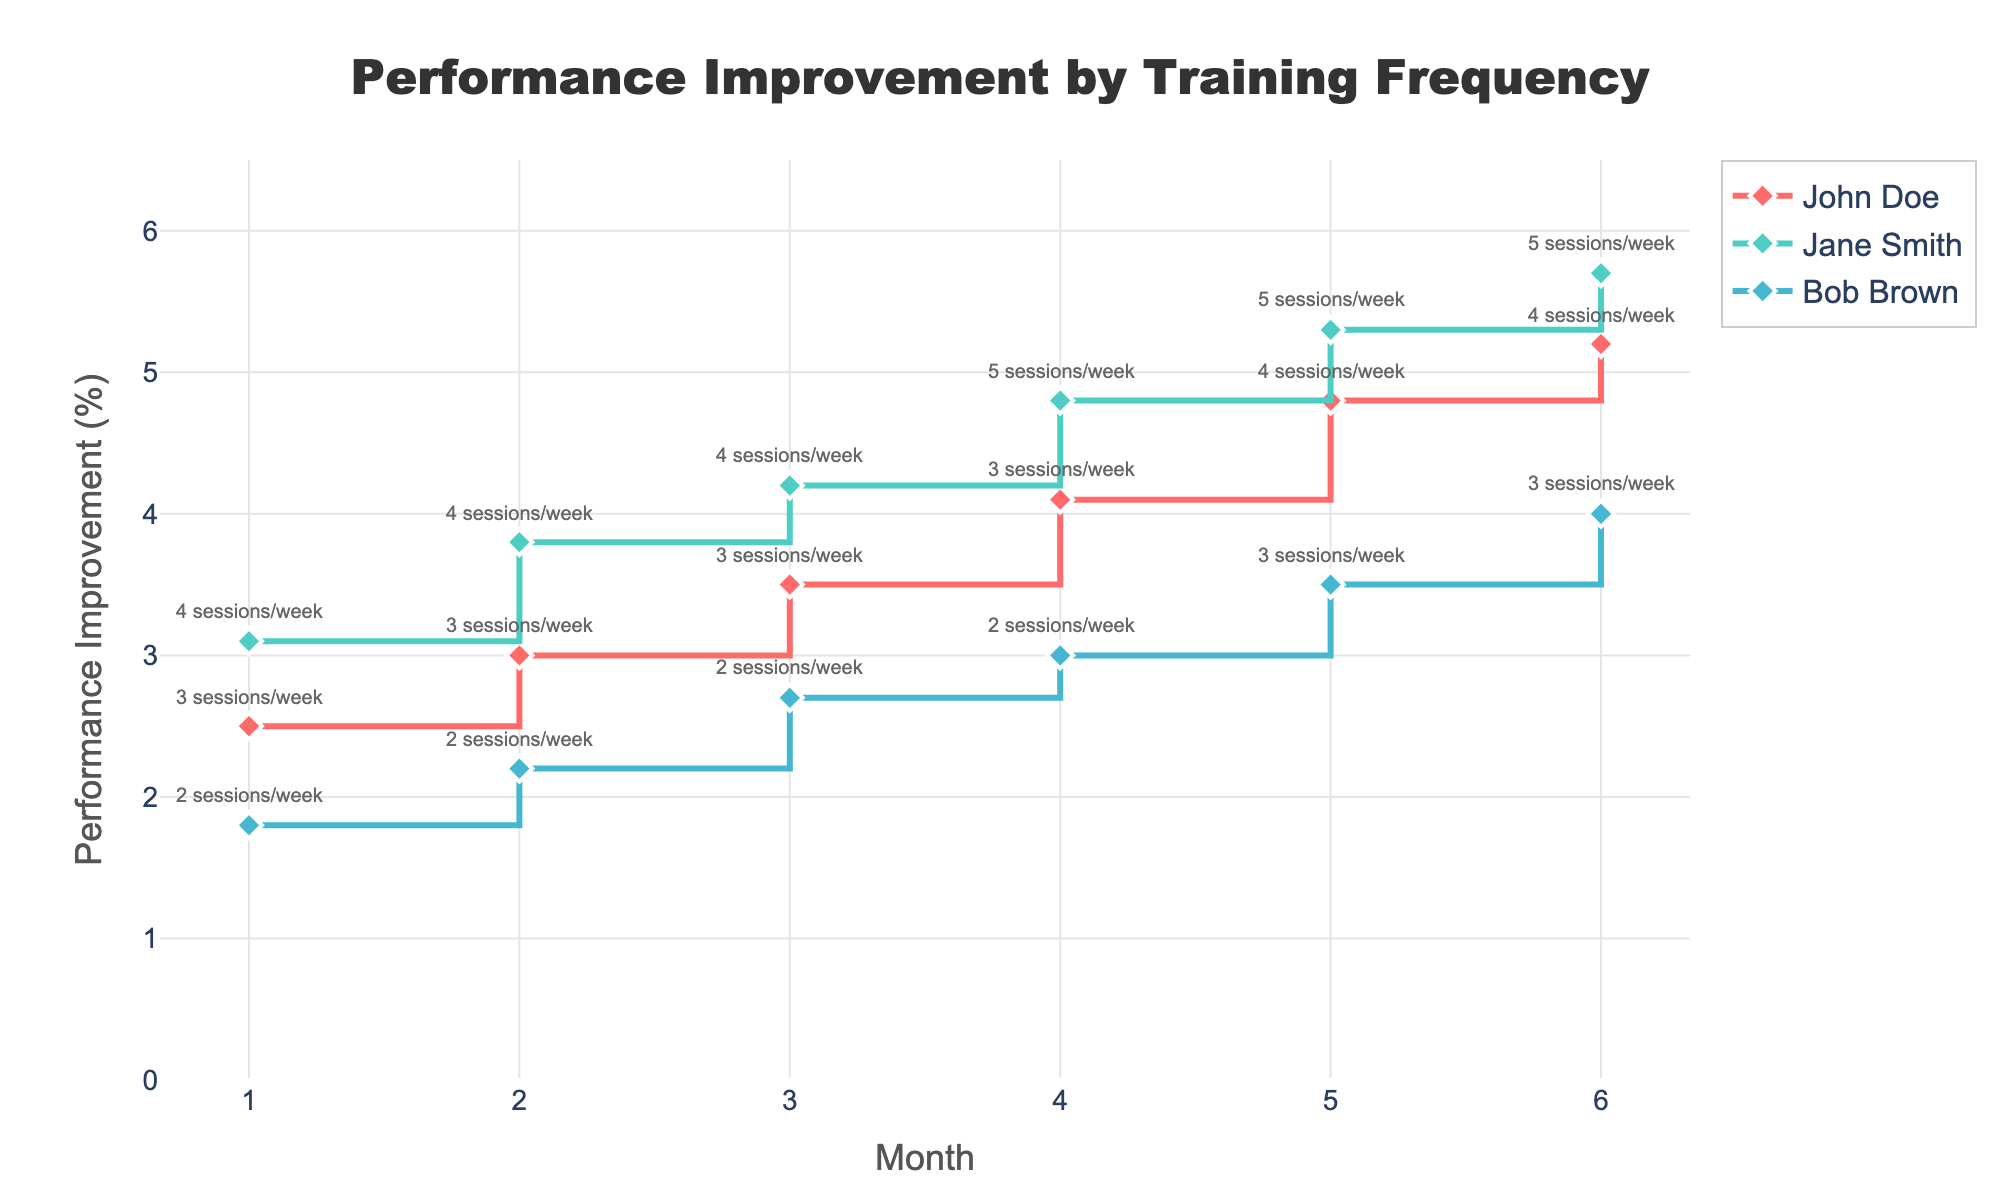What is the title of the plot? The title is displayed at the top of the plot and reads "Performance Improvement by Training Frequency".
Answer: Performance Improvement by Training Frequency How many athletes' performance improvements are tracked in the plot? The legend in the plot lists each athlete being tracked. There are three athletes shown: John Doe, Jane Smith, and Bob Brown.
Answer: 3 Which athlete has the highest performance improvement in Month 6? From the data points in Month 6, Jane Smith has the highest performance improvement at 5.7%.
Answer: Jane Smith What is the average performance improvement for Bob Brown over the 6 months? Calculate Bob Brown’s performance improvements for each month: 1.8, 2.2, 2.7, 3.0, 3.5, and 4.0. Sum these values and divide by the number of months (6). The sum is 17.2, so the average is 17.2/6.
Answer: 2.87% How did John Doe's training frequency change from Month 3 to Month 5? In Month 3, John Doe's training frequency was 3 sessions/week. By Month 5, it increased to 4 sessions/week.
Answer: Increased Who had the most consistent training frequency over the 6 months? By examining the annotations, we can see that Bob Brown maintained a consistent frequency of 2 sessions/week for the first 4 months before increasing to 3 sessions/week in the last 2 months. Therefore, Bob Brown had the most consistent training frequency.
Answer: Bob Brown What is the difference in performance improvement between John Doe and Jane Smith in Month 4? In Month 4, John Doe's performance improvement was 4.1%, and Jane Smith’s was 4.8%. The difference is calculated as 4.8% - 4.1% = 0.7%.
Answer: 0.7% By how much did Jane Smith's performance improvement increase from Month 1 to Month 6? Jane Smith’s performance improvements were 3.1% in Month 1 and 5.7% in Month 6. The increase is 5.7% - 3.1% = 2.6%.
Answer: 2.6% If you average the performance improvements of all three athletes in Month 2, what value do you get? Summing the improvements for Month 2: John Doe (3.0%), Jane Smith (3.8%), and Bob Brown (2.2%) gives 3.0 + 3.8 + 2.2 = 9.0. Dividing by 3 athletes gives an average of 9.0/3.
Answer: 3.0% Between which months did John Doe experience the highest single-month improvement? John's performance improvements were 2.5, 3.0, 3.5, 4.1, 4.8, and 5.2 over the months. The biggest jump is from Month 4 to Month 5 which is 4.8 - 4.1 = 0.7%.
Answer: Month 4 to Month 5 